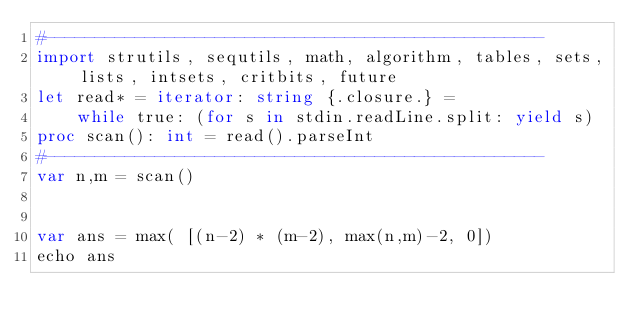Convert code to text. <code><loc_0><loc_0><loc_500><loc_500><_Nim_>#--------------------------------------------------
import strutils, sequtils, math, algorithm, tables, sets, lists, intsets, critbits, future
let read* = iterator: string {.closure.} =
    while true: (for s in stdin.readLine.split: yield s)
proc scan(): int = read().parseInt
#--------------------------------------------------
var n,m = scan()


var ans = max( [(n-2) * (m-2), max(n,m)-2, 0])
echo ans</code> 